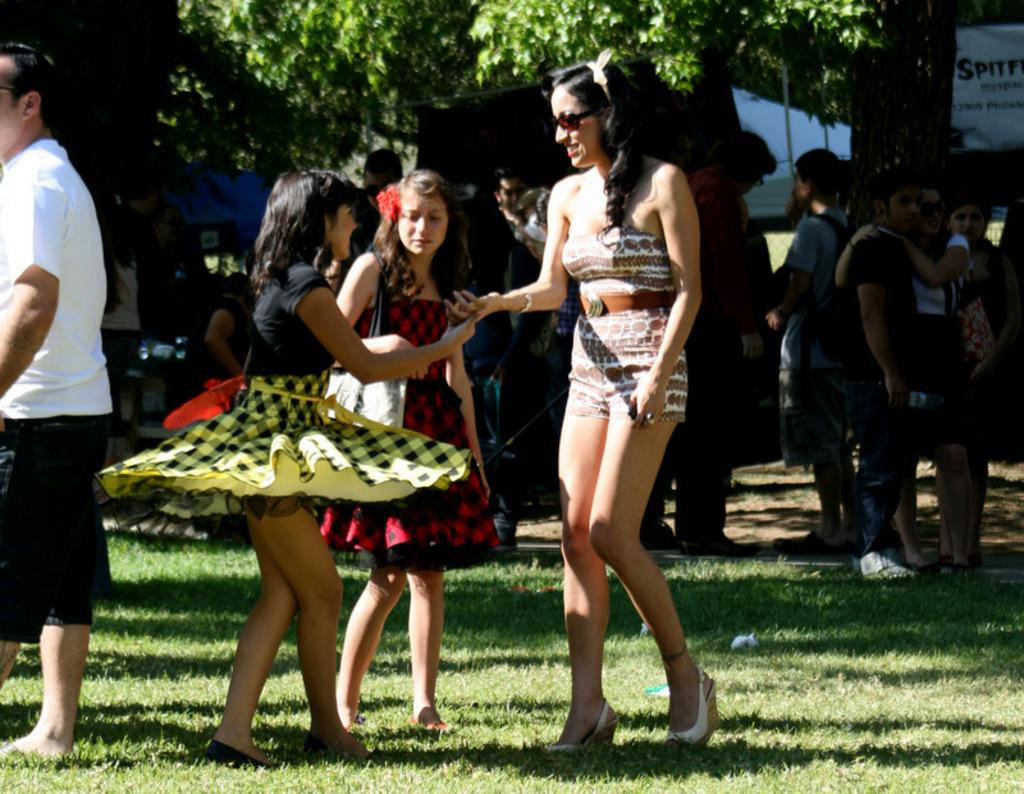Who is present in the image? There are people in the image. Can you describe the expressions of the people in the foreground? Two women are smiling in the foreground. What type of natural environment is visible in the image? There is grass visible in the image. What can be seen in the background of the image? Trees are present in the background of the image. What type of tooth is visible in the image? There is no tooth present in the image. Can you describe the spark coming from the cow in the image? There is no cow or spark present in the image. 